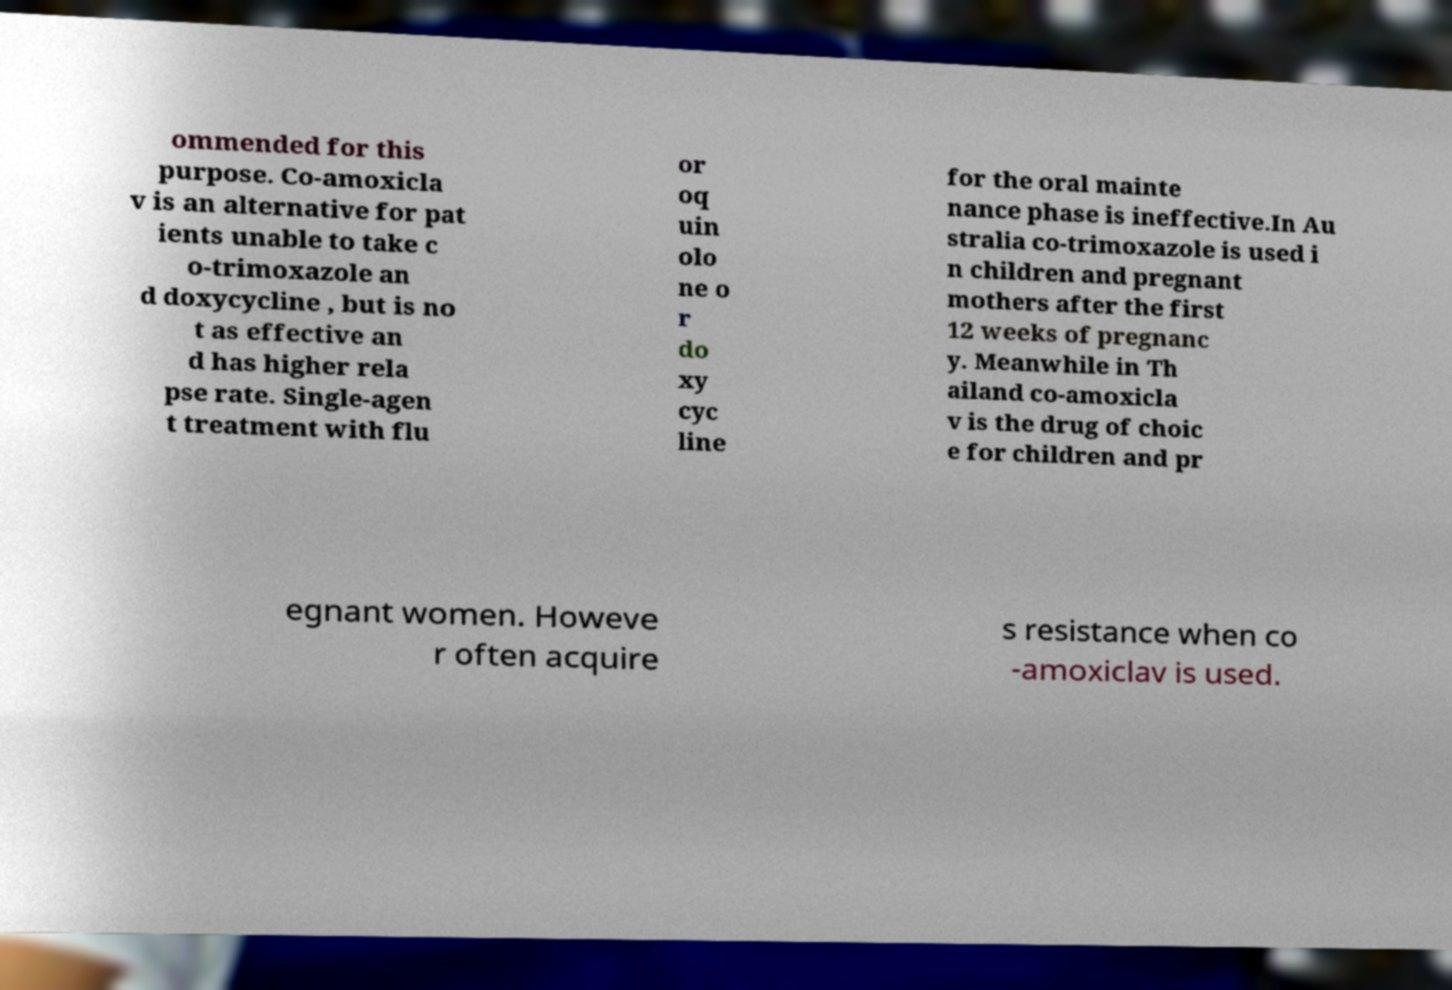Can you read and provide the text displayed in the image?This photo seems to have some interesting text. Can you extract and type it out for me? ommended for this purpose. Co-amoxicla v is an alternative for pat ients unable to take c o-trimoxazole an d doxycycline , but is no t as effective an d has higher rela pse rate. Single-agen t treatment with flu or oq uin olo ne o r do xy cyc line for the oral mainte nance phase is ineffective.In Au stralia co-trimoxazole is used i n children and pregnant mothers after the first 12 weeks of pregnanc y. Meanwhile in Th ailand co-amoxicla v is the drug of choic e for children and pr egnant women. Howeve r often acquire s resistance when co -amoxiclav is used. 